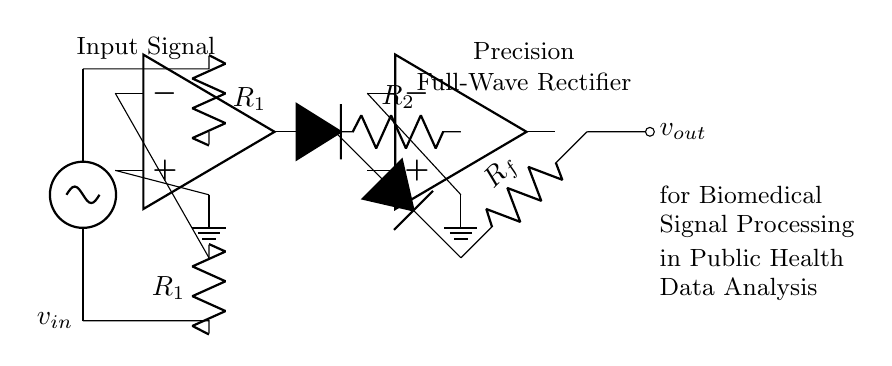What is the type of rectifier depicted in the circuit? The circuit diagram shows a precision full-wave rectifier which is designed to convert both halves of an input waveform into a corresponding output signal.
Answer: precision full-wave rectifier What components are connected to the output of the operational amplifiers? The output of the operational amplifiers is connected to diodes followed by a resistor, indicating that both op-amps combine to allow full-wave rectification of the input signal.
Answer: diodes and resistor How many operational amplifiers are used in this circuit? There are two operational amplifiers present in the circuit which are used to perform the full-wave rectification of the input signal.
Answer: two What do the resistors labeled R1, R2, and Rf represent in this circuit? R1 influences the input signal levels, R2 is part of feedback to control gain, while Rf sets the output stage's response; together, they determine the precision of the rectification process.
Answer: R1, R2, and Rf have specific roles affecting gain and response What is the purpose of the diodes in this precision rectifier circuit? The diodes serve to allow current to flow in one direction, thus rectifying the input signal by enabling it to produce a positive output regardless of the input signal's polarity.
Answer: rectify the input signal Where can you find the ground references in the circuit? The ground references are located at the negative inputs of the operational amplifiers, indicating the reference points for the input and feedback pathways in the circuit.
Answer: negative inputs of operational amplifiers 